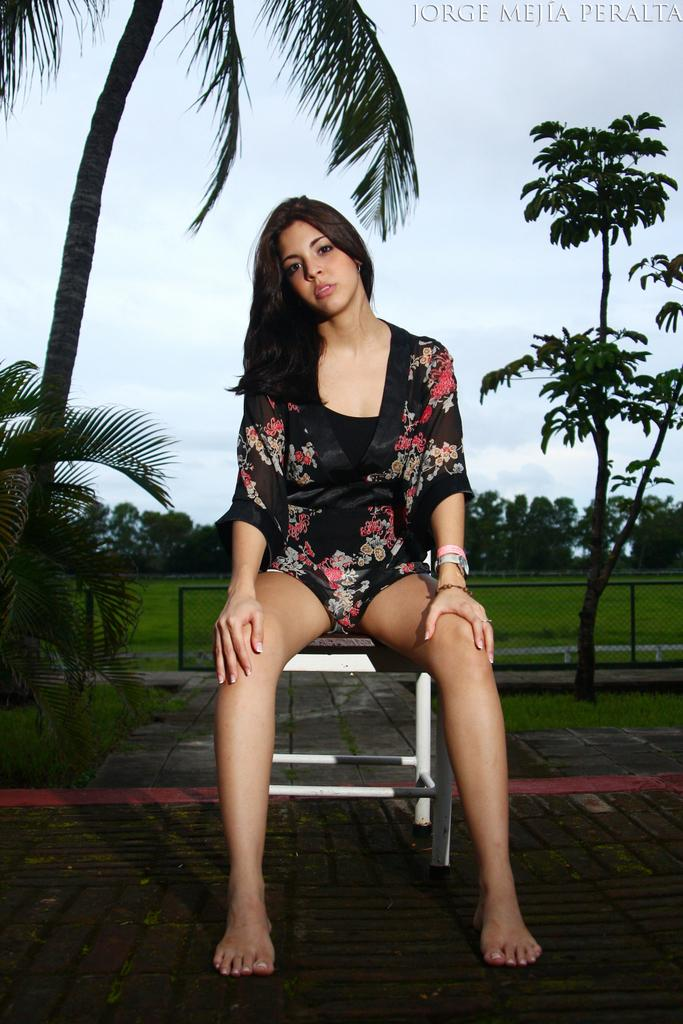What is the woman in the image doing? The woman is sitting on a chair in the image. What can be seen in the background of the image? There are trees in the background of the image. What is the condition of the sky in the image? The sky is clear in the image. Can you describe any additional features of the image? There is a watermark at the top right of the image. What type of owl can be seen perched on the woman's shoulder in the image? There is no owl present in the image; the woman is sitting on a chair without any animals. 